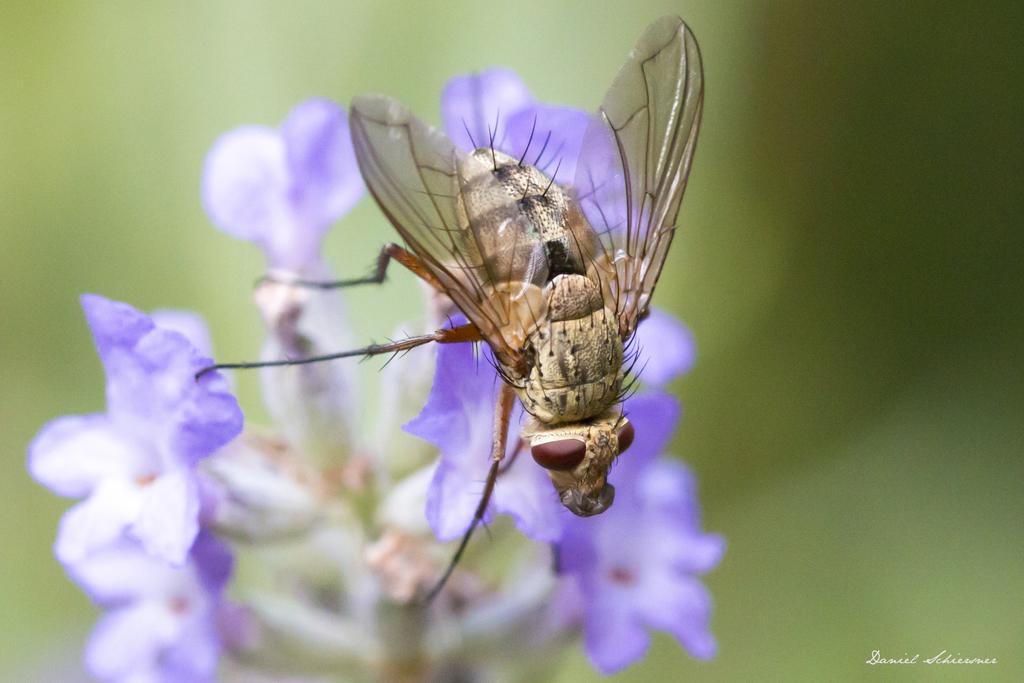In one or two sentences, can you explain what this image depicts? In this image there is an insect sitting on the flower. In the center there are flowers and the background is blurry. 